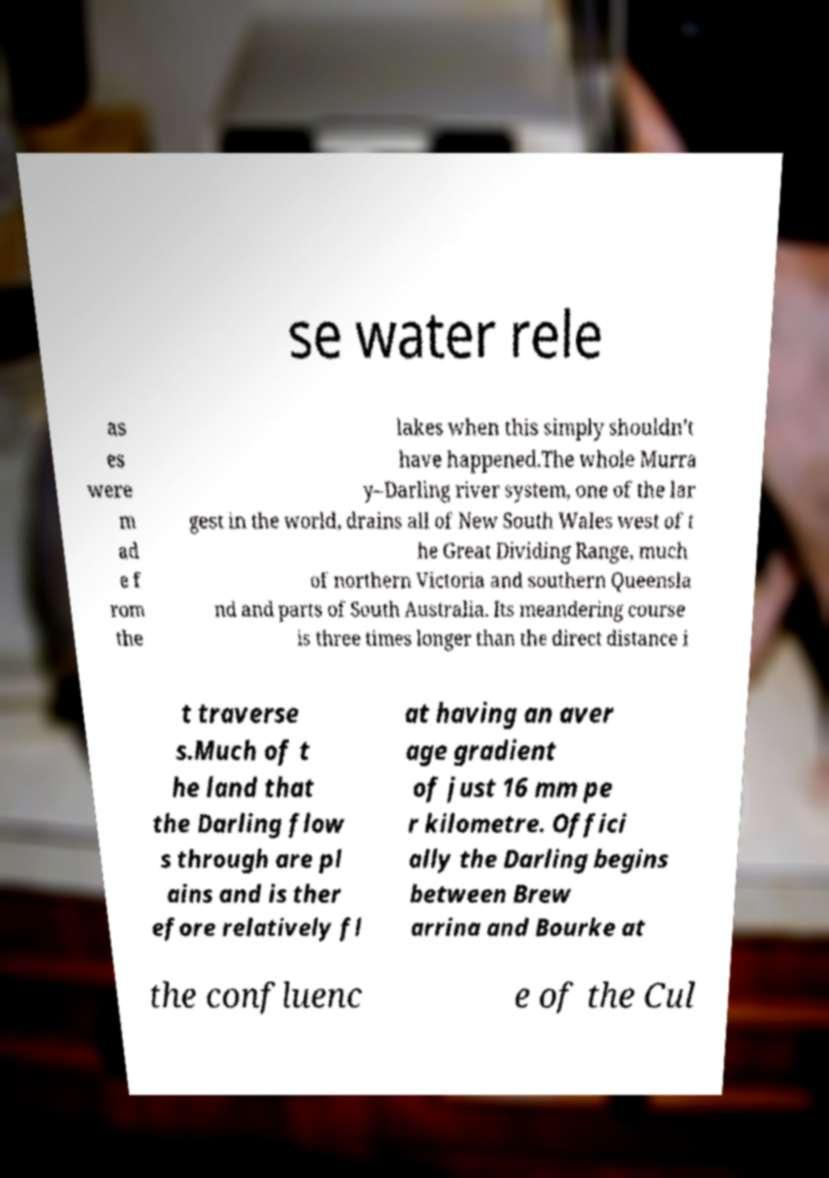Could you assist in decoding the text presented in this image and type it out clearly? se water rele as es were m ad e f rom the lakes when this simply shouldn’t have happened.The whole Murra y–Darling river system, one of the lar gest in the world, drains all of New South Wales west of t he Great Dividing Range, much of northern Victoria and southern Queensla nd and parts of South Australia. Its meandering course is three times longer than the direct distance i t traverse s.Much of t he land that the Darling flow s through are pl ains and is ther efore relatively fl at having an aver age gradient of just 16 mm pe r kilometre. Offici ally the Darling begins between Brew arrina and Bourke at the confluenc e of the Cul 